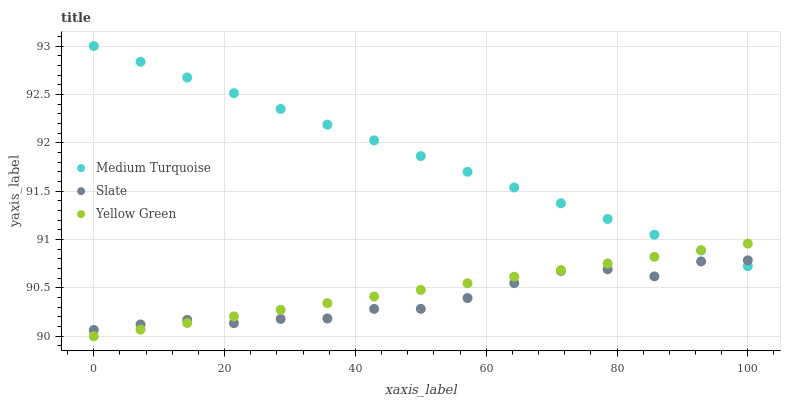Does Slate have the minimum area under the curve?
Answer yes or no. Yes. Does Medium Turquoise have the maximum area under the curve?
Answer yes or no. Yes. Does Yellow Green have the minimum area under the curve?
Answer yes or no. No. Does Yellow Green have the maximum area under the curve?
Answer yes or no. No. Is Medium Turquoise the smoothest?
Answer yes or no. Yes. Is Slate the roughest?
Answer yes or no. Yes. Is Yellow Green the smoothest?
Answer yes or no. No. Is Yellow Green the roughest?
Answer yes or no. No. Does Yellow Green have the lowest value?
Answer yes or no. Yes. Does Medium Turquoise have the lowest value?
Answer yes or no. No. Does Medium Turquoise have the highest value?
Answer yes or no. Yes. Does Yellow Green have the highest value?
Answer yes or no. No. Does Medium Turquoise intersect Yellow Green?
Answer yes or no. Yes. Is Medium Turquoise less than Yellow Green?
Answer yes or no. No. Is Medium Turquoise greater than Yellow Green?
Answer yes or no. No. 